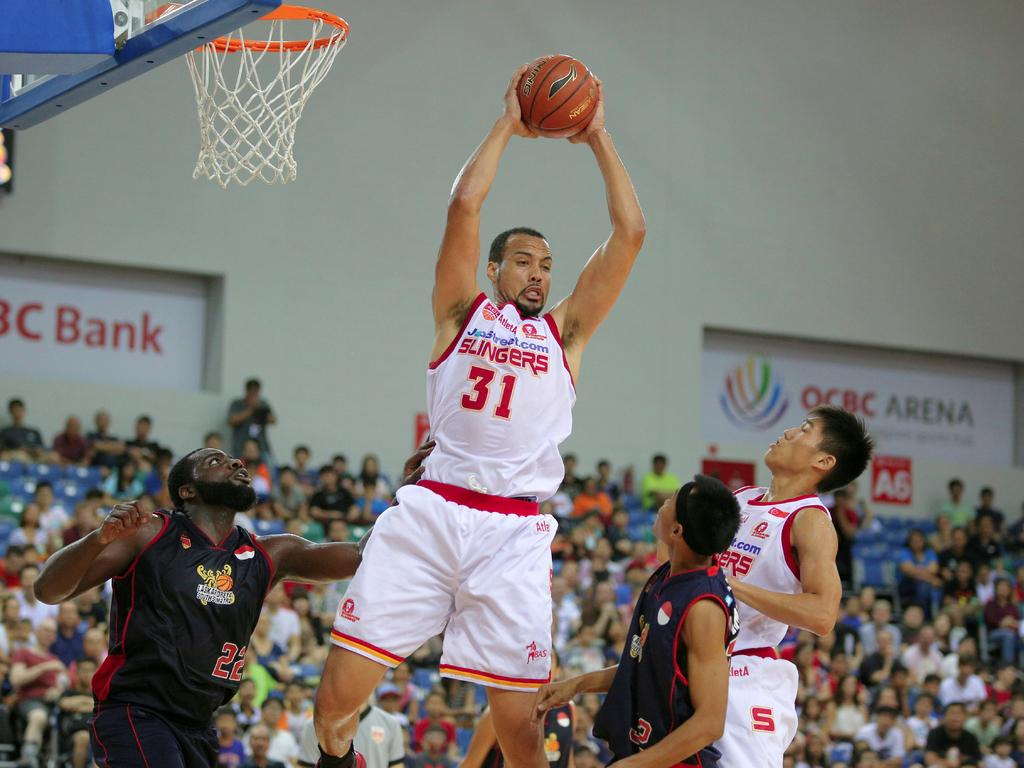<image>
Provide a brief description of the given image. Player number 31 for the Slingers grabbing a rebound. 